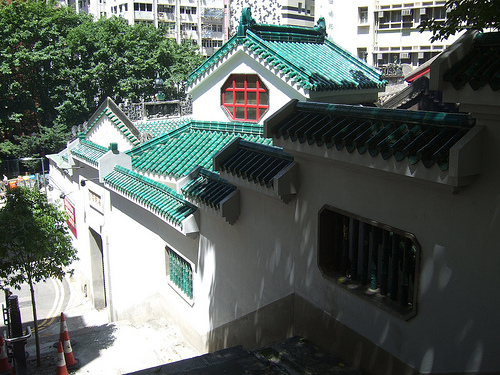<image>
Is the street sign under the leaf? Yes. The street sign is positioned underneath the leaf, with the leaf above it in the vertical space. 